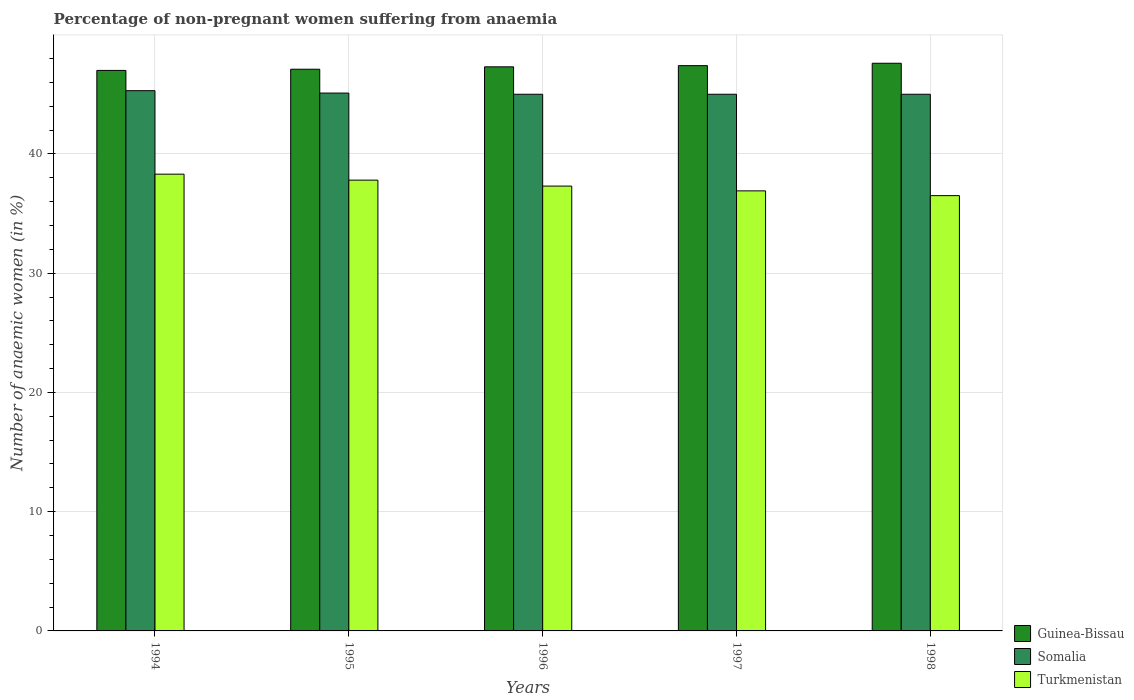How many different coloured bars are there?
Offer a terse response. 3. How many bars are there on the 5th tick from the left?
Your response must be concise. 3. What is the label of the 1st group of bars from the left?
Ensure brevity in your answer.  1994. In how many cases, is the number of bars for a given year not equal to the number of legend labels?
Your response must be concise. 0. What is the percentage of non-pregnant women suffering from anaemia in Somalia in 1994?
Offer a very short reply. 45.3. Across all years, what is the maximum percentage of non-pregnant women suffering from anaemia in Guinea-Bissau?
Keep it short and to the point. 47.6. Across all years, what is the minimum percentage of non-pregnant women suffering from anaemia in Turkmenistan?
Your response must be concise. 36.5. In which year was the percentage of non-pregnant women suffering from anaemia in Guinea-Bissau minimum?
Provide a succinct answer. 1994. What is the total percentage of non-pregnant women suffering from anaemia in Somalia in the graph?
Ensure brevity in your answer.  225.4. What is the difference between the percentage of non-pregnant women suffering from anaemia in Guinea-Bissau in 1998 and the percentage of non-pregnant women suffering from anaemia in Somalia in 1995?
Offer a terse response. 2.5. What is the average percentage of non-pregnant women suffering from anaemia in Turkmenistan per year?
Your answer should be very brief. 37.36. In the year 1998, what is the difference between the percentage of non-pregnant women suffering from anaemia in Somalia and percentage of non-pregnant women suffering from anaemia in Turkmenistan?
Provide a short and direct response. 8.5. In how many years, is the percentage of non-pregnant women suffering from anaemia in Guinea-Bissau greater than 46 %?
Ensure brevity in your answer.  5. Is the percentage of non-pregnant women suffering from anaemia in Turkmenistan in 1997 less than that in 1998?
Your answer should be very brief. No. Is the difference between the percentage of non-pregnant women suffering from anaemia in Somalia in 1996 and 1998 greater than the difference between the percentage of non-pregnant women suffering from anaemia in Turkmenistan in 1996 and 1998?
Provide a short and direct response. No. What is the difference between the highest and the second highest percentage of non-pregnant women suffering from anaemia in Somalia?
Provide a succinct answer. 0.2. What is the difference between the highest and the lowest percentage of non-pregnant women suffering from anaemia in Guinea-Bissau?
Your answer should be very brief. 0.6. In how many years, is the percentage of non-pregnant women suffering from anaemia in Somalia greater than the average percentage of non-pregnant women suffering from anaemia in Somalia taken over all years?
Your answer should be compact. 2. Is the sum of the percentage of non-pregnant women suffering from anaemia in Guinea-Bissau in 1994 and 1996 greater than the maximum percentage of non-pregnant women suffering from anaemia in Turkmenistan across all years?
Provide a short and direct response. Yes. What does the 2nd bar from the left in 1998 represents?
Offer a terse response. Somalia. What does the 3rd bar from the right in 1995 represents?
Offer a terse response. Guinea-Bissau. Is it the case that in every year, the sum of the percentage of non-pregnant women suffering from anaemia in Guinea-Bissau and percentage of non-pregnant women suffering from anaemia in Turkmenistan is greater than the percentage of non-pregnant women suffering from anaemia in Somalia?
Offer a terse response. Yes. Are all the bars in the graph horizontal?
Your response must be concise. No. How many years are there in the graph?
Ensure brevity in your answer.  5. What is the difference between two consecutive major ticks on the Y-axis?
Offer a very short reply. 10. Does the graph contain any zero values?
Ensure brevity in your answer.  No. What is the title of the graph?
Ensure brevity in your answer.  Percentage of non-pregnant women suffering from anaemia. What is the label or title of the X-axis?
Ensure brevity in your answer.  Years. What is the label or title of the Y-axis?
Make the answer very short. Number of anaemic women (in %). What is the Number of anaemic women (in %) of Guinea-Bissau in 1994?
Offer a very short reply. 47. What is the Number of anaemic women (in %) of Somalia in 1994?
Keep it short and to the point. 45.3. What is the Number of anaemic women (in %) of Turkmenistan in 1994?
Provide a succinct answer. 38.3. What is the Number of anaemic women (in %) in Guinea-Bissau in 1995?
Make the answer very short. 47.1. What is the Number of anaemic women (in %) of Somalia in 1995?
Your response must be concise. 45.1. What is the Number of anaemic women (in %) in Turkmenistan in 1995?
Ensure brevity in your answer.  37.8. What is the Number of anaemic women (in %) of Guinea-Bissau in 1996?
Give a very brief answer. 47.3. What is the Number of anaemic women (in %) of Somalia in 1996?
Ensure brevity in your answer.  45. What is the Number of anaemic women (in %) in Turkmenistan in 1996?
Keep it short and to the point. 37.3. What is the Number of anaemic women (in %) of Guinea-Bissau in 1997?
Keep it short and to the point. 47.4. What is the Number of anaemic women (in %) in Somalia in 1997?
Give a very brief answer. 45. What is the Number of anaemic women (in %) of Turkmenistan in 1997?
Keep it short and to the point. 36.9. What is the Number of anaemic women (in %) of Guinea-Bissau in 1998?
Your answer should be very brief. 47.6. What is the Number of anaemic women (in %) of Turkmenistan in 1998?
Ensure brevity in your answer.  36.5. Across all years, what is the maximum Number of anaemic women (in %) of Guinea-Bissau?
Your answer should be compact. 47.6. Across all years, what is the maximum Number of anaemic women (in %) in Somalia?
Your answer should be very brief. 45.3. Across all years, what is the maximum Number of anaemic women (in %) in Turkmenistan?
Your answer should be compact. 38.3. Across all years, what is the minimum Number of anaemic women (in %) in Guinea-Bissau?
Make the answer very short. 47. Across all years, what is the minimum Number of anaemic women (in %) of Somalia?
Offer a terse response. 45. Across all years, what is the minimum Number of anaemic women (in %) in Turkmenistan?
Provide a succinct answer. 36.5. What is the total Number of anaemic women (in %) in Guinea-Bissau in the graph?
Your answer should be compact. 236.4. What is the total Number of anaemic women (in %) of Somalia in the graph?
Your answer should be compact. 225.4. What is the total Number of anaemic women (in %) in Turkmenistan in the graph?
Make the answer very short. 186.8. What is the difference between the Number of anaemic women (in %) of Guinea-Bissau in 1994 and that in 1996?
Provide a short and direct response. -0.3. What is the difference between the Number of anaemic women (in %) of Somalia in 1994 and that in 1997?
Your answer should be compact. 0.3. What is the difference between the Number of anaemic women (in %) of Turkmenistan in 1994 and that in 1998?
Provide a succinct answer. 1.8. What is the difference between the Number of anaemic women (in %) in Guinea-Bissau in 1995 and that in 1996?
Give a very brief answer. -0.2. What is the difference between the Number of anaemic women (in %) in Somalia in 1995 and that in 1996?
Your response must be concise. 0.1. What is the difference between the Number of anaemic women (in %) in Guinea-Bissau in 1995 and that in 1997?
Keep it short and to the point. -0.3. What is the difference between the Number of anaemic women (in %) of Somalia in 1995 and that in 1997?
Make the answer very short. 0.1. What is the difference between the Number of anaemic women (in %) in Guinea-Bissau in 1995 and that in 1998?
Give a very brief answer. -0.5. What is the difference between the Number of anaemic women (in %) of Somalia in 1995 and that in 1998?
Provide a short and direct response. 0.1. What is the difference between the Number of anaemic women (in %) of Turkmenistan in 1995 and that in 1998?
Keep it short and to the point. 1.3. What is the difference between the Number of anaemic women (in %) of Somalia in 1996 and that in 1997?
Make the answer very short. 0. What is the difference between the Number of anaemic women (in %) of Guinea-Bissau in 1996 and that in 1998?
Your answer should be very brief. -0.3. What is the difference between the Number of anaemic women (in %) of Somalia in 1996 and that in 1998?
Offer a very short reply. 0. What is the difference between the Number of anaemic women (in %) of Turkmenistan in 1996 and that in 1998?
Ensure brevity in your answer.  0.8. What is the difference between the Number of anaemic women (in %) of Somalia in 1994 and the Number of anaemic women (in %) of Turkmenistan in 1995?
Keep it short and to the point. 7.5. What is the difference between the Number of anaemic women (in %) of Guinea-Bissau in 1994 and the Number of anaemic women (in %) of Somalia in 1996?
Offer a terse response. 2. What is the difference between the Number of anaemic women (in %) in Guinea-Bissau in 1994 and the Number of anaemic women (in %) in Somalia in 1997?
Give a very brief answer. 2. What is the difference between the Number of anaemic women (in %) in Guinea-Bissau in 1994 and the Number of anaemic women (in %) in Somalia in 1998?
Make the answer very short. 2. What is the difference between the Number of anaemic women (in %) of Guinea-Bissau in 1994 and the Number of anaemic women (in %) of Turkmenistan in 1998?
Make the answer very short. 10.5. What is the difference between the Number of anaemic women (in %) of Somalia in 1994 and the Number of anaemic women (in %) of Turkmenistan in 1998?
Your response must be concise. 8.8. What is the difference between the Number of anaemic women (in %) of Guinea-Bissau in 1995 and the Number of anaemic women (in %) of Turkmenistan in 1996?
Offer a terse response. 9.8. What is the difference between the Number of anaemic women (in %) of Somalia in 1995 and the Number of anaemic women (in %) of Turkmenistan in 1996?
Keep it short and to the point. 7.8. What is the difference between the Number of anaemic women (in %) in Guinea-Bissau in 1995 and the Number of anaemic women (in %) in Somalia in 1997?
Offer a very short reply. 2.1. What is the difference between the Number of anaemic women (in %) in Guinea-Bissau in 1995 and the Number of anaemic women (in %) in Turkmenistan in 1997?
Offer a very short reply. 10.2. What is the difference between the Number of anaemic women (in %) in Somalia in 1995 and the Number of anaemic women (in %) in Turkmenistan in 1997?
Provide a short and direct response. 8.2. What is the difference between the Number of anaemic women (in %) in Somalia in 1995 and the Number of anaemic women (in %) in Turkmenistan in 1998?
Keep it short and to the point. 8.6. What is the difference between the Number of anaemic women (in %) in Guinea-Bissau in 1996 and the Number of anaemic women (in %) in Somalia in 1997?
Give a very brief answer. 2.3. What is the difference between the Number of anaemic women (in %) in Somalia in 1996 and the Number of anaemic women (in %) in Turkmenistan in 1997?
Ensure brevity in your answer.  8.1. What is the difference between the Number of anaemic women (in %) in Somalia in 1996 and the Number of anaemic women (in %) in Turkmenistan in 1998?
Your response must be concise. 8.5. What is the difference between the Number of anaemic women (in %) of Guinea-Bissau in 1997 and the Number of anaemic women (in %) of Somalia in 1998?
Ensure brevity in your answer.  2.4. What is the difference between the Number of anaemic women (in %) of Somalia in 1997 and the Number of anaemic women (in %) of Turkmenistan in 1998?
Make the answer very short. 8.5. What is the average Number of anaemic women (in %) in Guinea-Bissau per year?
Your answer should be compact. 47.28. What is the average Number of anaemic women (in %) in Somalia per year?
Provide a short and direct response. 45.08. What is the average Number of anaemic women (in %) in Turkmenistan per year?
Provide a succinct answer. 37.36. In the year 1995, what is the difference between the Number of anaemic women (in %) in Guinea-Bissau and Number of anaemic women (in %) in Somalia?
Offer a very short reply. 2. In the year 1995, what is the difference between the Number of anaemic women (in %) of Somalia and Number of anaemic women (in %) of Turkmenistan?
Make the answer very short. 7.3. In the year 1996, what is the difference between the Number of anaemic women (in %) of Guinea-Bissau and Number of anaemic women (in %) of Somalia?
Your answer should be compact. 2.3. In the year 1996, what is the difference between the Number of anaemic women (in %) in Guinea-Bissau and Number of anaemic women (in %) in Turkmenistan?
Offer a very short reply. 10. In the year 1996, what is the difference between the Number of anaemic women (in %) in Somalia and Number of anaemic women (in %) in Turkmenistan?
Your response must be concise. 7.7. In the year 1997, what is the difference between the Number of anaemic women (in %) of Guinea-Bissau and Number of anaemic women (in %) of Somalia?
Ensure brevity in your answer.  2.4. In the year 1997, what is the difference between the Number of anaemic women (in %) of Guinea-Bissau and Number of anaemic women (in %) of Turkmenistan?
Give a very brief answer. 10.5. In the year 1997, what is the difference between the Number of anaemic women (in %) of Somalia and Number of anaemic women (in %) of Turkmenistan?
Provide a short and direct response. 8.1. In the year 1998, what is the difference between the Number of anaemic women (in %) in Guinea-Bissau and Number of anaemic women (in %) in Turkmenistan?
Give a very brief answer. 11.1. In the year 1998, what is the difference between the Number of anaemic women (in %) of Somalia and Number of anaemic women (in %) of Turkmenistan?
Keep it short and to the point. 8.5. What is the ratio of the Number of anaemic women (in %) of Somalia in 1994 to that in 1995?
Provide a short and direct response. 1. What is the ratio of the Number of anaemic women (in %) of Turkmenistan in 1994 to that in 1995?
Provide a succinct answer. 1.01. What is the ratio of the Number of anaemic women (in %) in Guinea-Bissau in 1994 to that in 1996?
Offer a very short reply. 0.99. What is the ratio of the Number of anaemic women (in %) in Somalia in 1994 to that in 1996?
Offer a terse response. 1.01. What is the ratio of the Number of anaemic women (in %) of Turkmenistan in 1994 to that in 1996?
Ensure brevity in your answer.  1.03. What is the ratio of the Number of anaemic women (in %) of Guinea-Bissau in 1994 to that in 1997?
Give a very brief answer. 0.99. What is the ratio of the Number of anaemic women (in %) in Somalia in 1994 to that in 1997?
Make the answer very short. 1.01. What is the ratio of the Number of anaemic women (in %) of Turkmenistan in 1994 to that in 1997?
Offer a terse response. 1.04. What is the ratio of the Number of anaemic women (in %) in Guinea-Bissau in 1994 to that in 1998?
Provide a short and direct response. 0.99. What is the ratio of the Number of anaemic women (in %) of Somalia in 1994 to that in 1998?
Your answer should be very brief. 1.01. What is the ratio of the Number of anaemic women (in %) in Turkmenistan in 1994 to that in 1998?
Make the answer very short. 1.05. What is the ratio of the Number of anaemic women (in %) in Turkmenistan in 1995 to that in 1996?
Offer a terse response. 1.01. What is the ratio of the Number of anaemic women (in %) in Turkmenistan in 1995 to that in 1997?
Offer a very short reply. 1.02. What is the ratio of the Number of anaemic women (in %) of Guinea-Bissau in 1995 to that in 1998?
Offer a very short reply. 0.99. What is the ratio of the Number of anaemic women (in %) of Somalia in 1995 to that in 1998?
Give a very brief answer. 1. What is the ratio of the Number of anaemic women (in %) in Turkmenistan in 1995 to that in 1998?
Make the answer very short. 1.04. What is the ratio of the Number of anaemic women (in %) of Guinea-Bissau in 1996 to that in 1997?
Keep it short and to the point. 1. What is the ratio of the Number of anaemic women (in %) of Somalia in 1996 to that in 1997?
Your answer should be compact. 1. What is the ratio of the Number of anaemic women (in %) in Turkmenistan in 1996 to that in 1997?
Ensure brevity in your answer.  1.01. What is the ratio of the Number of anaemic women (in %) in Guinea-Bissau in 1996 to that in 1998?
Make the answer very short. 0.99. What is the ratio of the Number of anaemic women (in %) in Somalia in 1996 to that in 1998?
Offer a terse response. 1. What is the ratio of the Number of anaemic women (in %) of Turkmenistan in 1996 to that in 1998?
Provide a short and direct response. 1.02. What is the ratio of the Number of anaemic women (in %) of Somalia in 1997 to that in 1998?
Keep it short and to the point. 1. What is the difference between the highest and the second highest Number of anaemic women (in %) of Somalia?
Your response must be concise. 0.2. What is the difference between the highest and the second highest Number of anaemic women (in %) of Turkmenistan?
Your answer should be very brief. 0.5. What is the difference between the highest and the lowest Number of anaemic women (in %) of Guinea-Bissau?
Provide a succinct answer. 0.6. What is the difference between the highest and the lowest Number of anaemic women (in %) in Turkmenistan?
Ensure brevity in your answer.  1.8. 